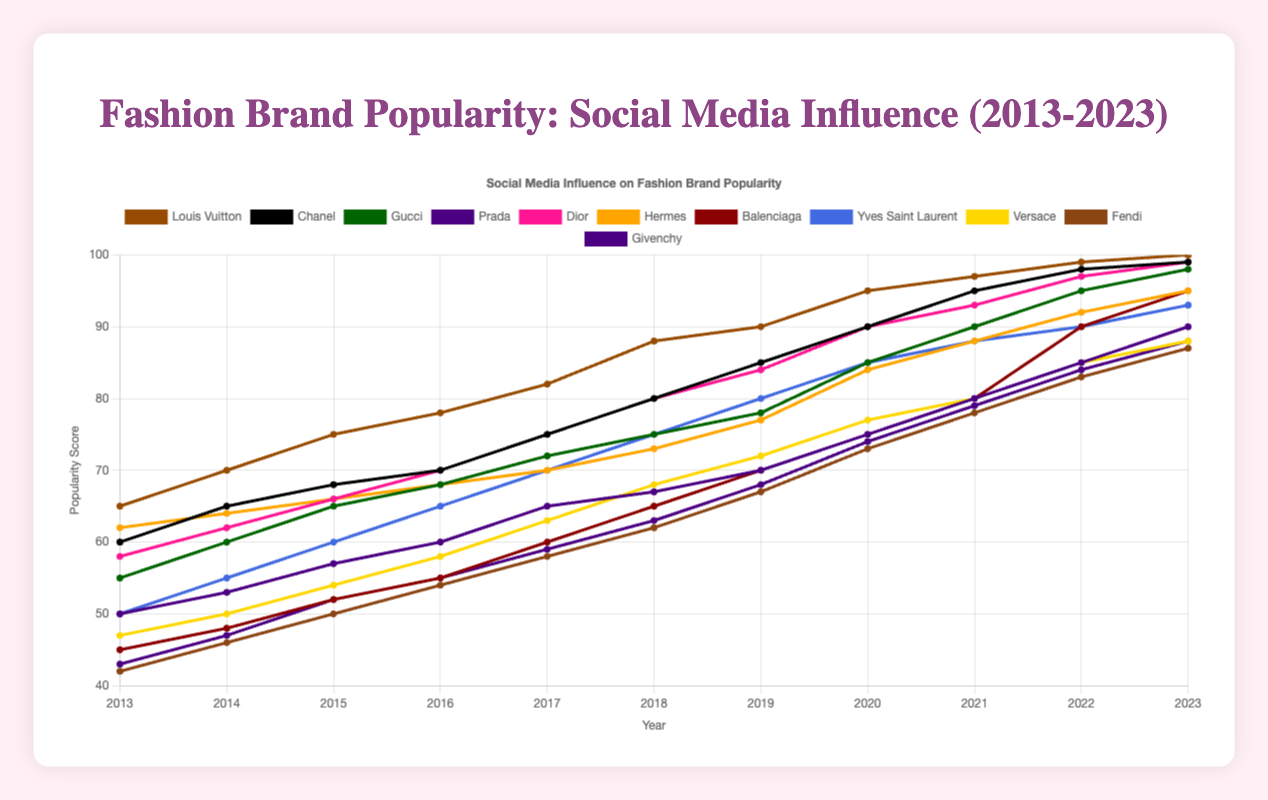What year did Louis Vuitton first reach a popularity score of 95? The line chart for Louis Vuitton shows that its popularity score reached 95 in the year 2020.
Answer: 2020 Which brand had the lowest popularity score in 2015? By visually examining the line chart for 2015, Fendi had the lowest popularity score of 50.
Answer: Fendi Compare the popularity scores of Dior and Gucci in 2023. Which brand was more popular and by how much? In 2023, Dior had a popularity score of 99, while Gucci had 98. Dior was more popular by (99 - 98) = 1 point.
Answer: Dior, by 1 point Which brand showed the highest increase in popularity from 2013 to 2023? By comparing the popularity scores of each brand from 2013 to 2023, Balenciaga showed the highest increase, from 45 to 95, an increase of 50 points.
Answer: Balenciaga What is the average popularity score of Chanel from 2018 to 2023? The popularity scores of Chanel from 2018 to 2023 are: 80, 85, 90, 95, 98, and 99. The average is (80 + 85 + 90 + 95 + 98 + 99) / 6 = 90.83.
Answer: 90.83 Which year did Givenchy's popularity score first exceed 50? The line chart for Givenchy shows that its score first exceeded 50 in 2015.
Answer: 2015 Between Hermes and Versace, which brand had a consistently upward trend in popularity from 2013 to 2023? By examining the trends, Hermes followed a steady upward trend each year, whereas Versace had a few years with unchanged or slow progress. Thus, Hermes had a more consistent upward trend.
Answer: Hermes What is the total increase in popularity score for Yves Saint Laurent from 2013 to 2023? Yves Saint Laurent's popularity score increased from 50 in 2013 to 93 in 2023. The total increase is 93 - 50 = 43.
Answer: 43 Which two brands had identical popularity scores in 2018? Looking at the chart data for 2018, both Dior and Chanel had a popularity score of 80.
Answer: Dior and Chanel 